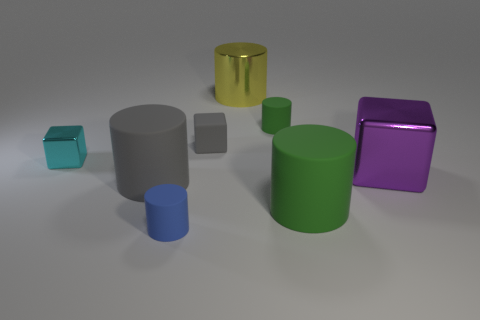Subtract all brown cylinders. Subtract all green cubes. How many cylinders are left? 5 Add 1 brown spheres. How many objects exist? 9 Subtract all cylinders. How many objects are left? 3 Add 8 green rubber things. How many green rubber things exist? 10 Subtract 0 purple cylinders. How many objects are left? 8 Subtract all big brown matte objects. Subtract all matte cylinders. How many objects are left? 4 Add 2 big gray cylinders. How many big gray cylinders are left? 3 